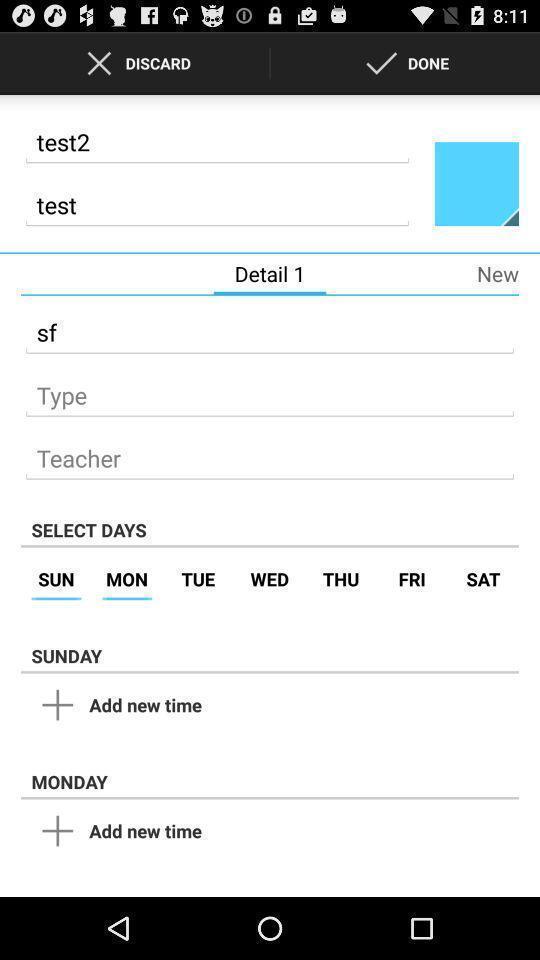Tell me about the visual elements in this screen capture. Page displaying to add new time select days in application. 